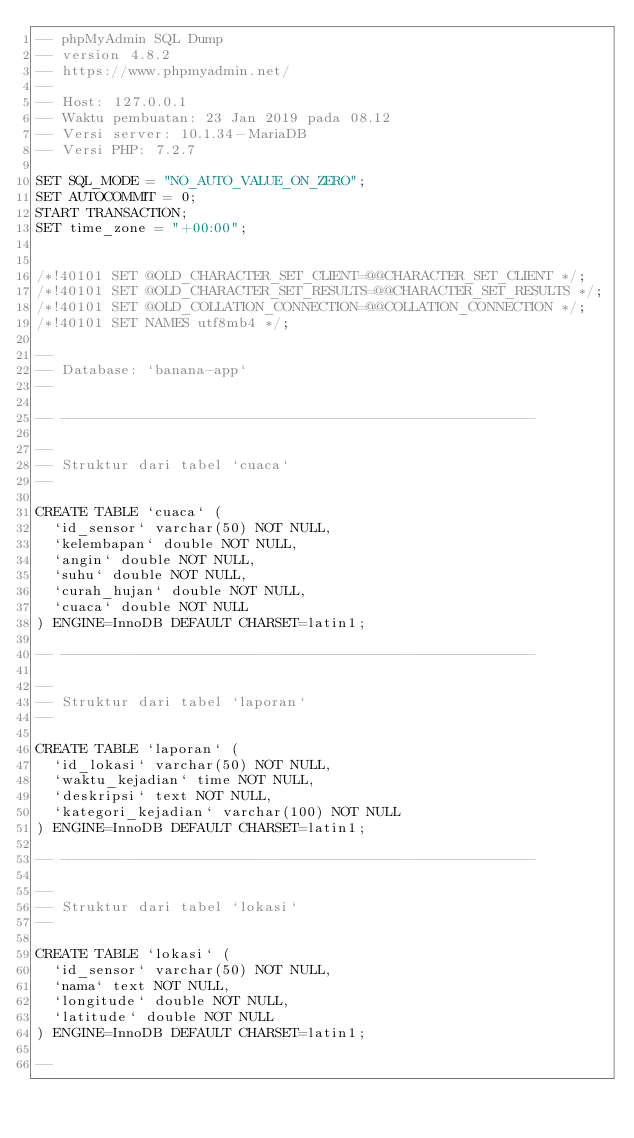<code> <loc_0><loc_0><loc_500><loc_500><_SQL_>-- phpMyAdmin SQL Dump
-- version 4.8.2
-- https://www.phpmyadmin.net/
--
-- Host: 127.0.0.1
-- Waktu pembuatan: 23 Jan 2019 pada 08.12
-- Versi server: 10.1.34-MariaDB
-- Versi PHP: 7.2.7

SET SQL_MODE = "NO_AUTO_VALUE_ON_ZERO";
SET AUTOCOMMIT = 0;
START TRANSACTION;
SET time_zone = "+00:00";


/*!40101 SET @OLD_CHARACTER_SET_CLIENT=@@CHARACTER_SET_CLIENT */;
/*!40101 SET @OLD_CHARACTER_SET_RESULTS=@@CHARACTER_SET_RESULTS */;
/*!40101 SET @OLD_COLLATION_CONNECTION=@@COLLATION_CONNECTION */;
/*!40101 SET NAMES utf8mb4 */;

--
-- Database: `banana-app`
--

-- --------------------------------------------------------

--
-- Struktur dari tabel `cuaca`
--

CREATE TABLE `cuaca` (
  `id_sensor` varchar(50) NOT NULL,
  `kelembapan` double NOT NULL,
  `angin` double NOT NULL,
  `suhu` double NOT NULL,
  `curah_hujan` double NOT NULL,
  `cuaca` double NOT NULL
) ENGINE=InnoDB DEFAULT CHARSET=latin1;

-- --------------------------------------------------------

--
-- Struktur dari tabel `laporan`
--

CREATE TABLE `laporan` (
  `id_lokasi` varchar(50) NOT NULL,
  `waktu_kejadian` time NOT NULL,
  `deskripsi` text NOT NULL,
  `kategori_kejadian` varchar(100) NOT NULL
) ENGINE=InnoDB DEFAULT CHARSET=latin1;

-- --------------------------------------------------------

--
-- Struktur dari tabel `lokasi`
--

CREATE TABLE `lokasi` (
  `id_sensor` varchar(50) NOT NULL,
  `nama` text NOT NULL,
  `longitude` double NOT NULL,
  `latitude` double NOT NULL
) ENGINE=InnoDB DEFAULT CHARSET=latin1;

--</code> 